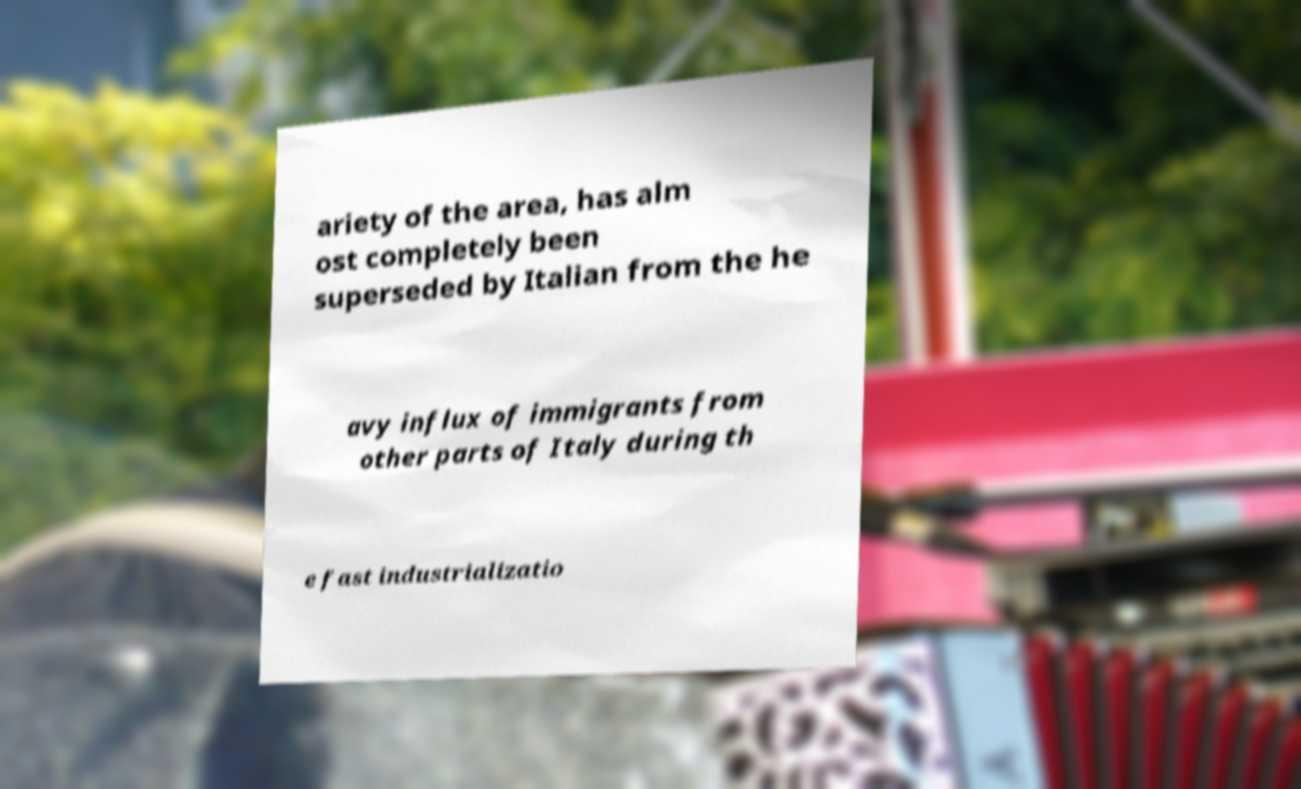Please identify and transcribe the text found in this image. ariety of the area, has alm ost completely been superseded by Italian from the he avy influx of immigrants from other parts of Italy during th e fast industrializatio 